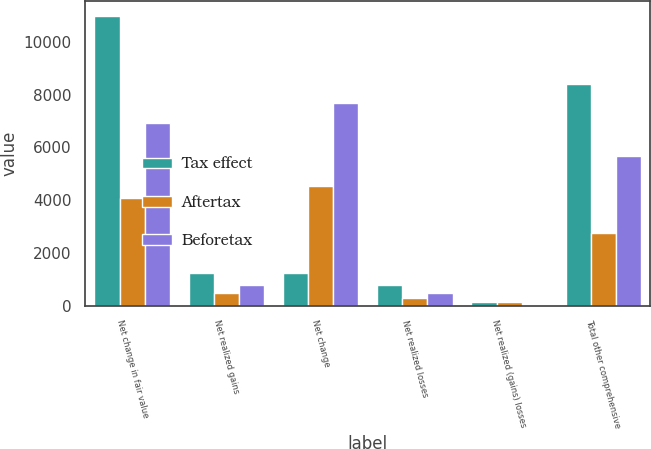Convert chart to OTSL. <chart><loc_0><loc_0><loc_500><loc_500><stacked_bar_chart><ecel><fcel>Net change in fair value<fcel>Net realized gains<fcel>Net change<fcel>Net realized losses<fcel>Net realized (gains) losses<fcel>Total other comprehensive<nl><fcel>Tax effect<fcel>10989<fcel>1251<fcel>1251<fcel>773<fcel>138<fcel>8400<nl><fcel>Aftertax<fcel>4077<fcel>463<fcel>4540<fcel>286<fcel>133<fcel>2740<nl><fcel>Beforetax<fcel>6912<fcel>788<fcel>7700<fcel>487<fcel>5<fcel>5660<nl></chart> 